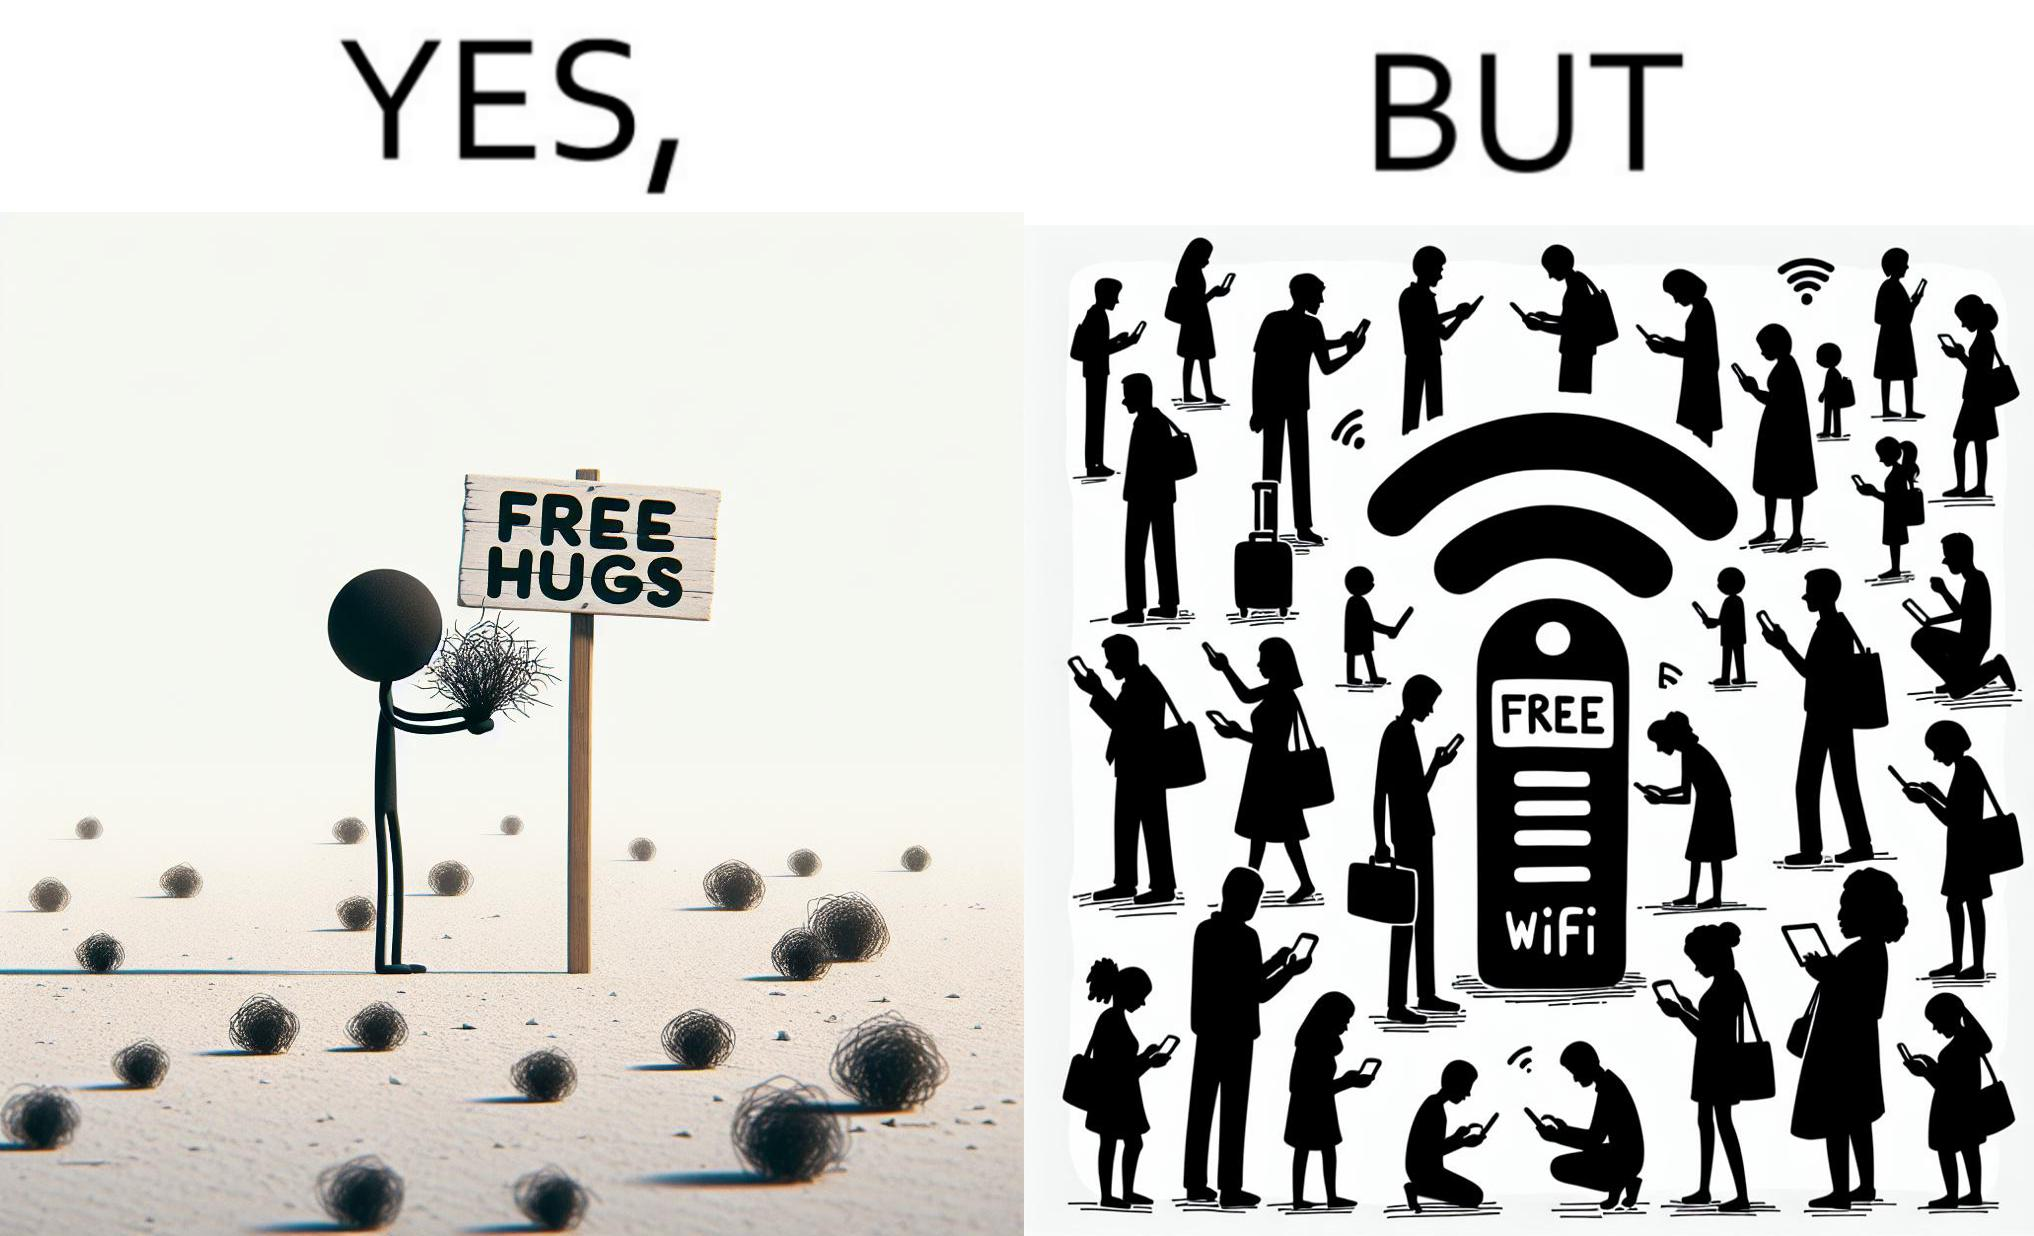Is there satirical content in this image? Yes, this image is satirical. 